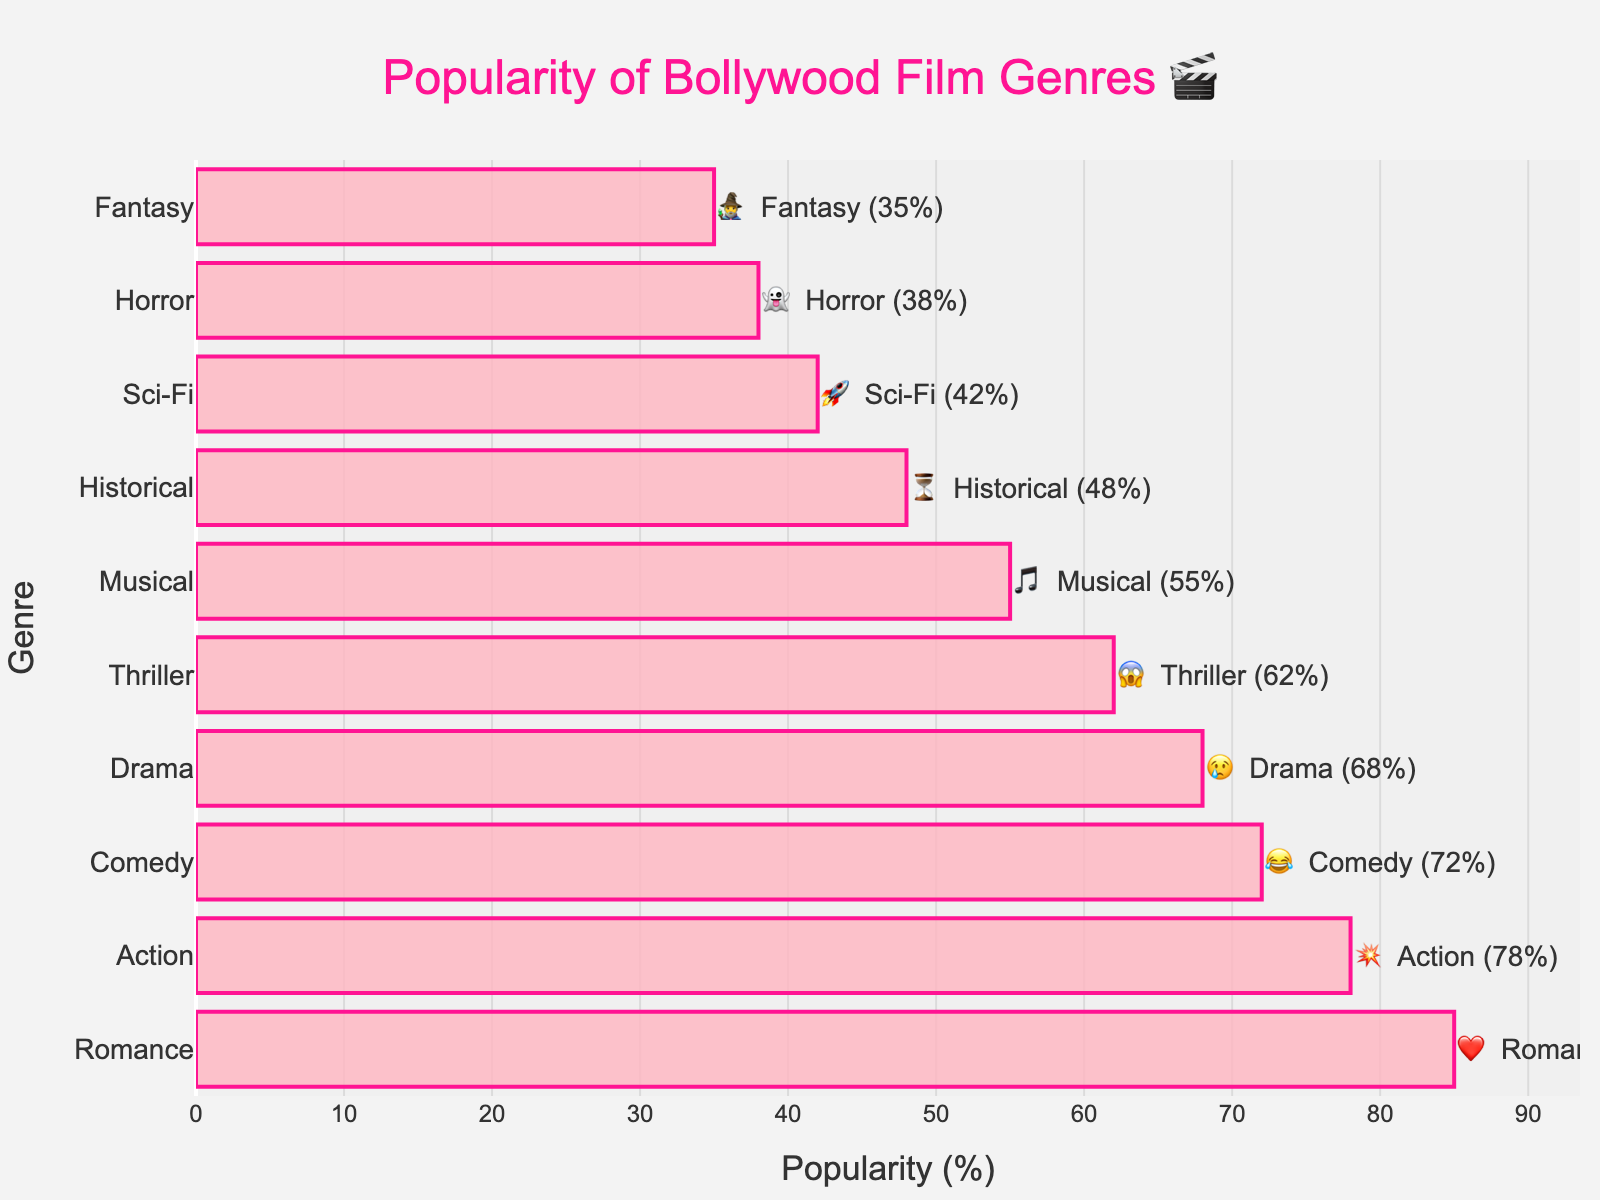What's the title of the chart? The title is usually located at the top of a chart. In this case, it's displayed prominently above the plot area. The text reads: "Popularity of Bollywood Film Genres 🎬"
Answer: Popularity of Bollywood Film Genres 🎬 Which genre has the highest popularity? By observing the length of the bars, the topmost bar typically represents the genre with the highest popularity. In this chart, it is the Romance genre.
Answer: Romance What is the emoji representation for the Action genre? The emoji for each genre is shown next to its name in the bar chart. For Action, the emoji next to it is 💥.
Answer: 💥 How much more popular is the Romance genre compared to the Historical genre? Locate the values for Romance (85%) and Historical (48%). The difference is calculated as 85 - 48 = 37%.
Answer: 37% What are the third and fourth most popular genres? The lengths and order of the bars from top to bottom indicate popularity. The third and fourth bars from the top show Comedy (72%) and Drama (68%), respectively.
Answer: Comedy and Drama Which genres have a popularity less than 50%? Identify bars with a value below 50%. The genres are Historical (48%), Sci-Fi (42%), Horror (38%), and Fantasy (35%).
Answer: Historical, Sci-Fi, Horror, and Fantasy What's the cumulative popularity of all the genres? Sum up the popularity percentages of all listed genres: 85 + 78 + 72 + 68 + 62 + 55 + 48 + 42 + 38 + 35 = 583%.
Answer: 583% How does the popularity of Musical compare to Thriller? Look at the values: Musical has 55% and Thriller has 62%. Thriller is more popular by 7%.
Answer: Thriller is more popular by 7% What is the color scheme used in the bars of the chart? The bars are pink with a slightly transparent appearance, and outlines are darker pink. This color scheme is consistent across all bars.
Answer: Pink with dark pink outlines Which genre has the closest popularity to 40%? Identify the genre with a value nearest to 40%. Sci-Fi has a popularity of 42%, which is closest to 40%.
Answer: Sci-Fi 